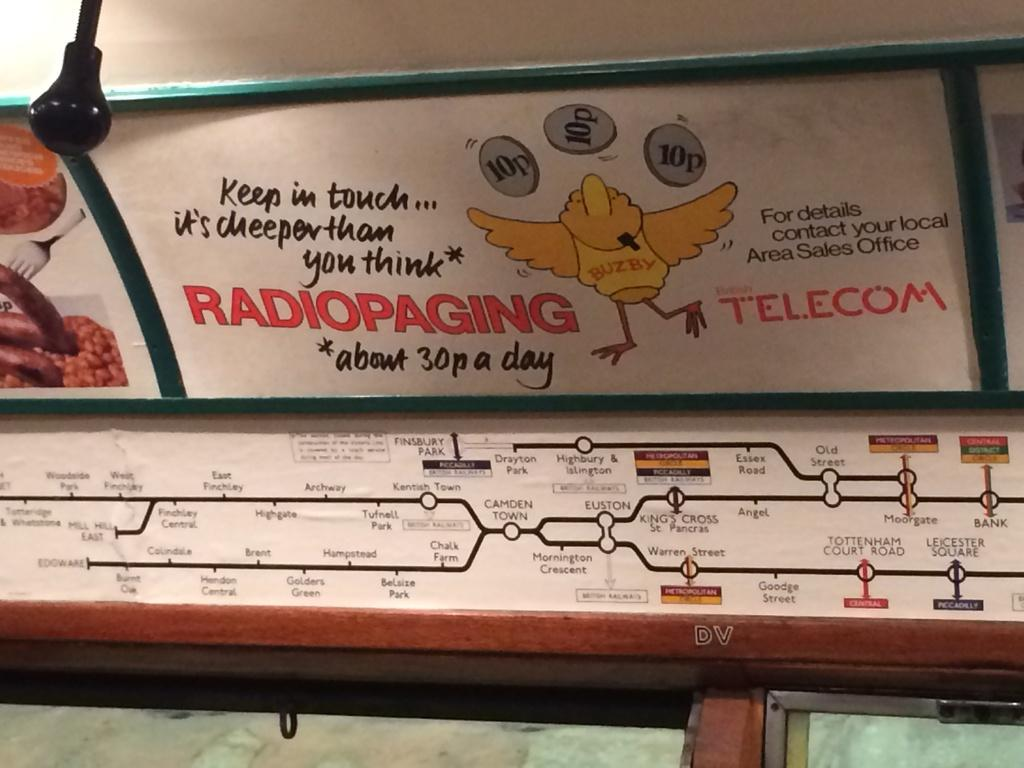<image>
Present a compact description of the photo's key features. a sign that says 'radiopaging telecom' on it 